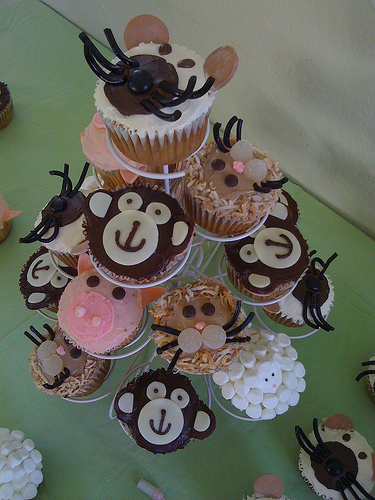<image>
Is there a monkey cupcake above the pig cupcake? Yes. The monkey cupcake is positioned above the pig cupcake in the vertical space, higher up in the scene. 